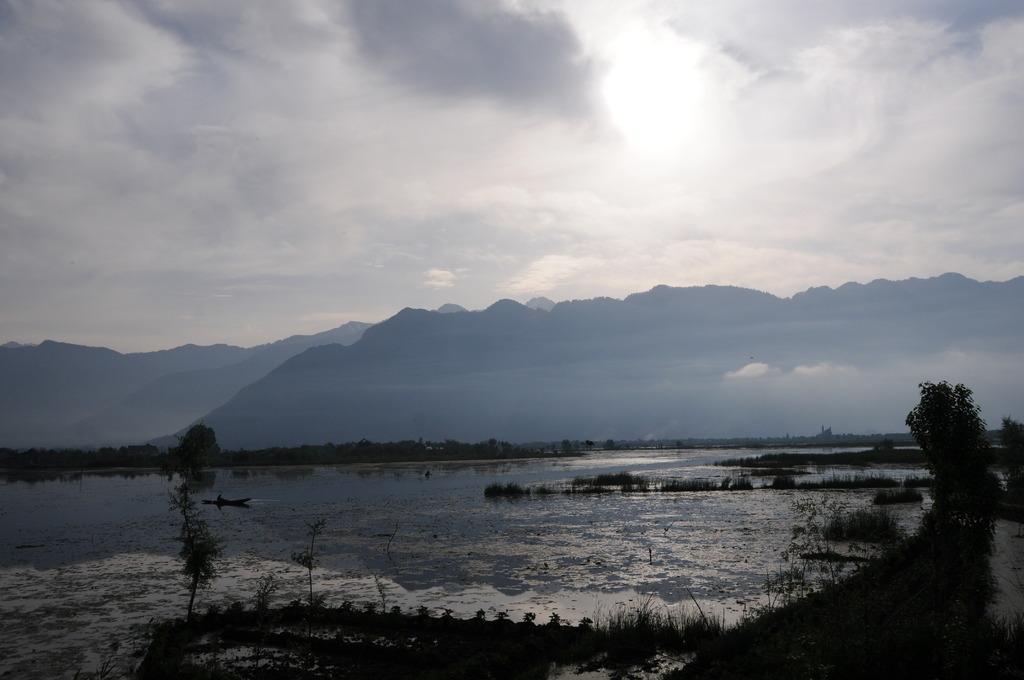Could you give a brief overview of what you see in this image? In this picture I can observe a river. I can observe some plants in the middle of the picture. In the background there are hills and clouds in the sky. 